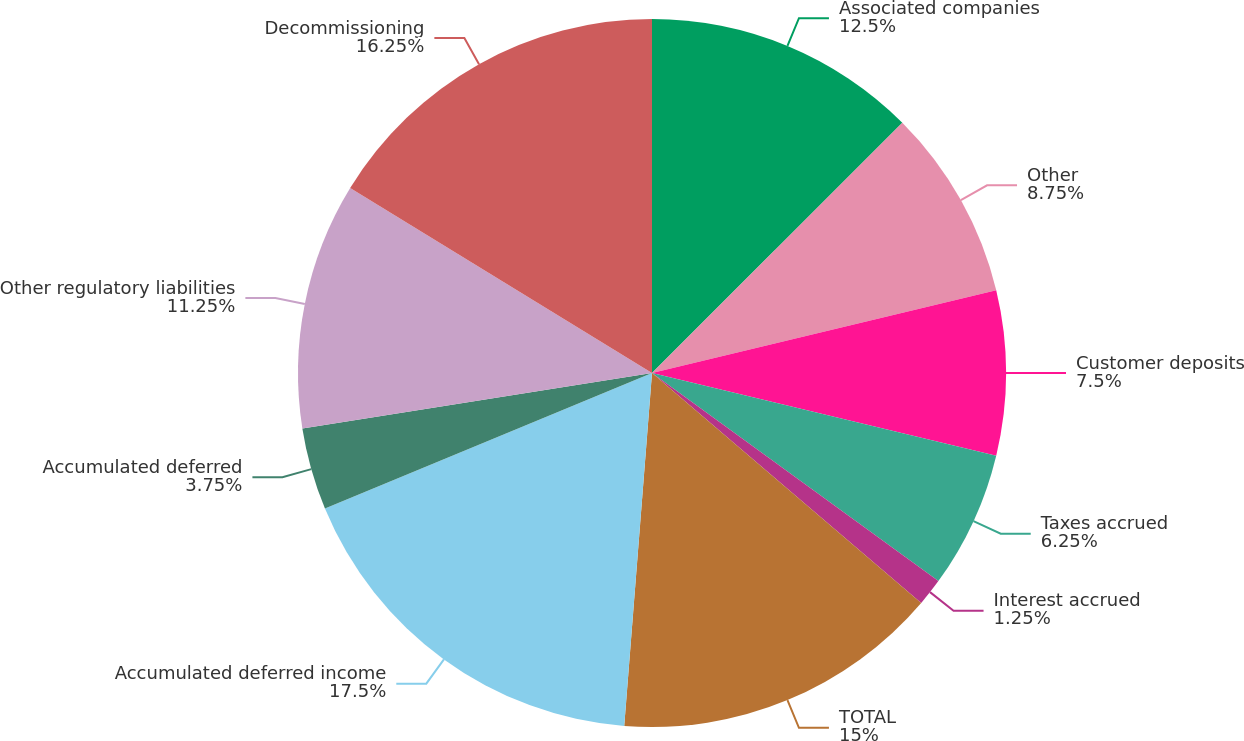Convert chart. <chart><loc_0><loc_0><loc_500><loc_500><pie_chart><fcel>Associated companies<fcel>Other<fcel>Customer deposits<fcel>Taxes accrued<fcel>Interest accrued<fcel>TOTAL<fcel>Accumulated deferred income<fcel>Accumulated deferred<fcel>Other regulatory liabilities<fcel>Decommissioning<nl><fcel>12.5%<fcel>8.75%<fcel>7.5%<fcel>6.25%<fcel>1.25%<fcel>15.0%<fcel>17.5%<fcel>3.75%<fcel>11.25%<fcel>16.25%<nl></chart> 